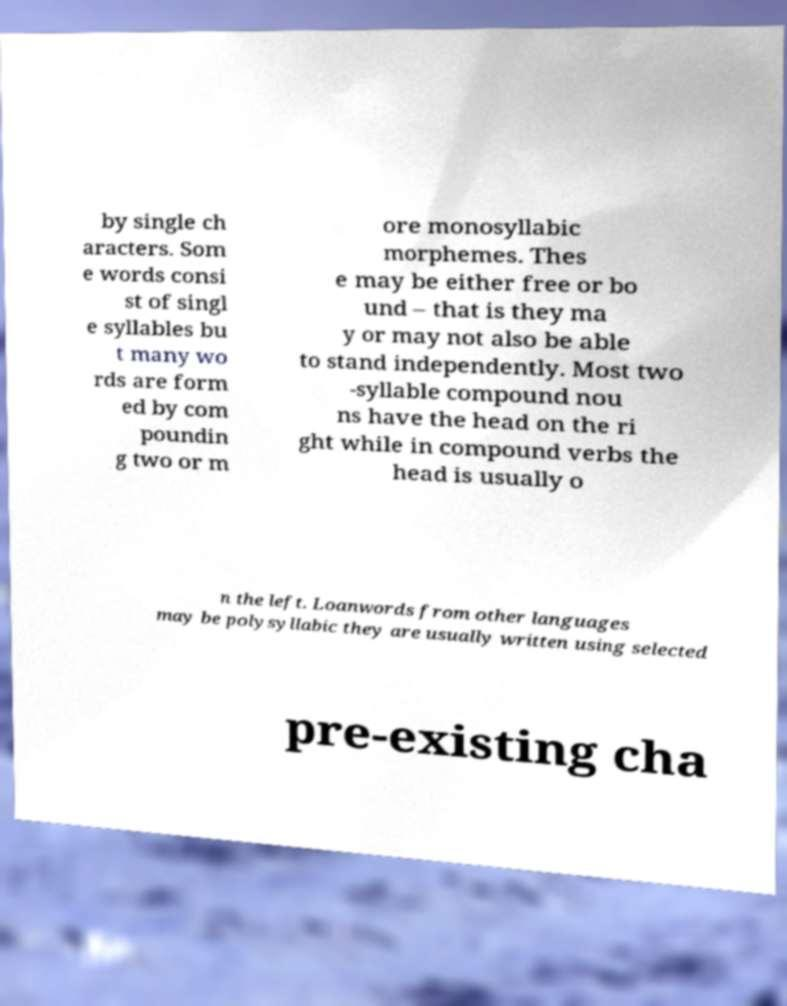For documentation purposes, I need the text within this image transcribed. Could you provide that? by single ch aracters. Som e words consi st of singl e syllables bu t many wo rds are form ed by com poundin g two or m ore monosyllabic morphemes. Thes e may be either free or bo und – that is they ma y or may not also be able to stand independently. Most two -syllable compound nou ns have the head on the ri ght while in compound verbs the head is usually o n the left. Loanwords from other languages may be polysyllabic they are usually written using selected pre-existing cha 